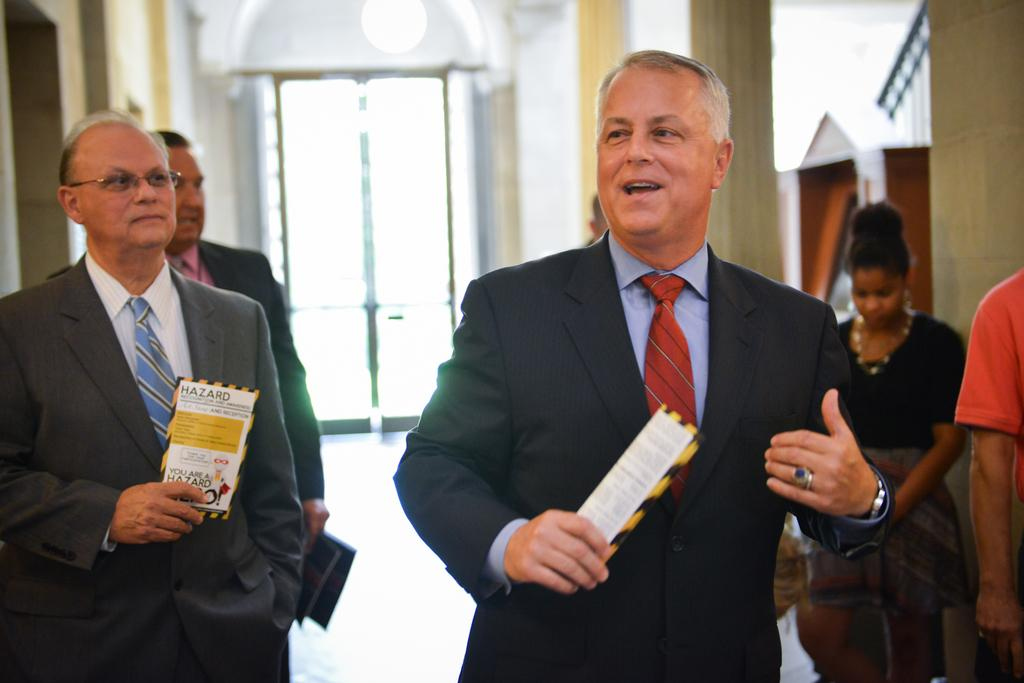What are the people in the image doing? The people in the image are walking. What are the people holding in their hands? The people are holding papers in their hands. What architectural features can be seen in the image? There are pillars and a wall visible in the image. What can be seen in the background of the image? There is a door visible in the background of the image. What type of throat can be seen in the image? There is no throat visible in the image. What is the base of the pillars made of in the image? The provided facts do not mention the material or base of the pillars, so it cannot be determined from the image. 